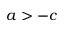<formula> <loc_0><loc_0><loc_500><loc_500>a > - c</formula> 